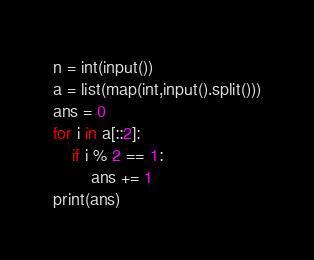<code> <loc_0><loc_0><loc_500><loc_500><_Python_>n = int(input())
a = list(map(int,input().split()))
ans = 0
for i in a[::2]:
    if i % 2 == 1:
        ans += 1
print(ans)</code> 